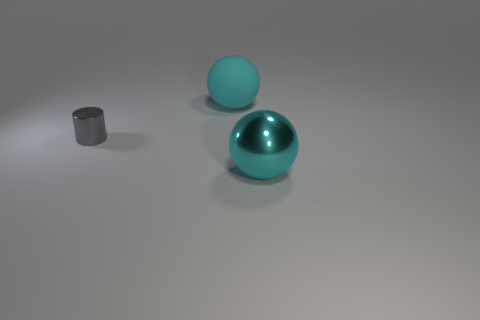How big is the shiny sphere?
Your response must be concise. Large. Is the number of objects on the left side of the small cylinder greater than the number of rubber spheres on the left side of the matte object?
Your answer should be very brief. No. What number of cyan things are to the left of the large cyan thing that is in front of the large rubber thing?
Your answer should be compact. 1. Is the shape of the large rubber object that is behind the cylinder the same as  the big metal object?
Your answer should be compact. Yes. What material is the other big cyan thing that is the same shape as the cyan rubber thing?
Your answer should be compact. Metal. How many gray cylinders are the same size as the gray thing?
Make the answer very short. 0. The object that is both in front of the matte thing and right of the gray thing is what color?
Provide a succinct answer. Cyan. Is the number of small metallic things less than the number of small gray rubber objects?
Offer a very short reply. No. Does the big rubber ball have the same color as the shiny object in front of the small metal cylinder?
Offer a terse response. Yes. Are there an equal number of things that are right of the gray metal object and things that are behind the big metallic object?
Your answer should be compact. Yes. 